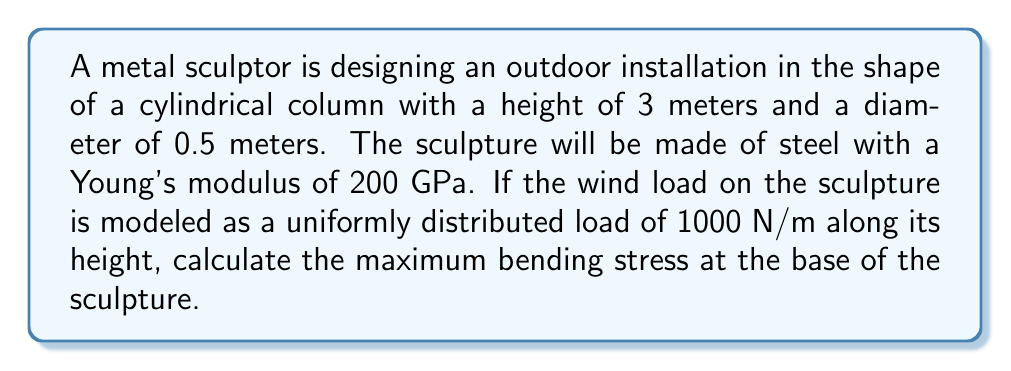Give your solution to this math problem. To solve this problem, we'll follow these steps:

1. Calculate the moment of inertia for the circular cross-section.
2. Determine the maximum bending moment at the base.
3. Calculate the maximum bending stress using the flexure formula.

Step 1: Moment of inertia for a circular cross-section

The moment of inertia (I) for a solid circular cross-section is given by:

$$ I = \frac{\pi r^4}{4} $$

Where r is the radius of the circle. In this case, r = 0.25 m (half the diameter).

$$ I = \frac{\pi (0.25 \text{ m})^4}{4} = 1.917 \times 10^{-4} \text{ m}^4 $$

Step 2: Maximum bending moment

For a uniformly distributed load (w) on a cantilever beam of length L, the maximum bending moment (M) occurs at the base and is given by:

$$ M = \frac{wL^2}{2} $$

Here, w = 1000 N/m and L = 3 m.

$$ M = \frac{1000 \text{ N/m} \cdot (3 \text{ m})^2}{2} = 4500 \text{ N·m} $$

Step 3: Maximum bending stress

The maximum bending stress (σ) can be calculated using the flexure formula:

$$ \sigma = \frac{My}{I} $$

Where y is the distance from the neutral axis to the outermost fiber (in this case, the radius of the cylinder).

$$ \sigma = \frac{4500 \text{ N·m} \cdot 0.25 \text{ m}}{1.917 \times 10^{-4} \text{ m}^4} = 5.866 \times 10^6 \text{ Pa} = 5.866 \text{ MPa} $$
Answer: The maximum bending stress at the base of the sculpture is 5.866 MPa. 